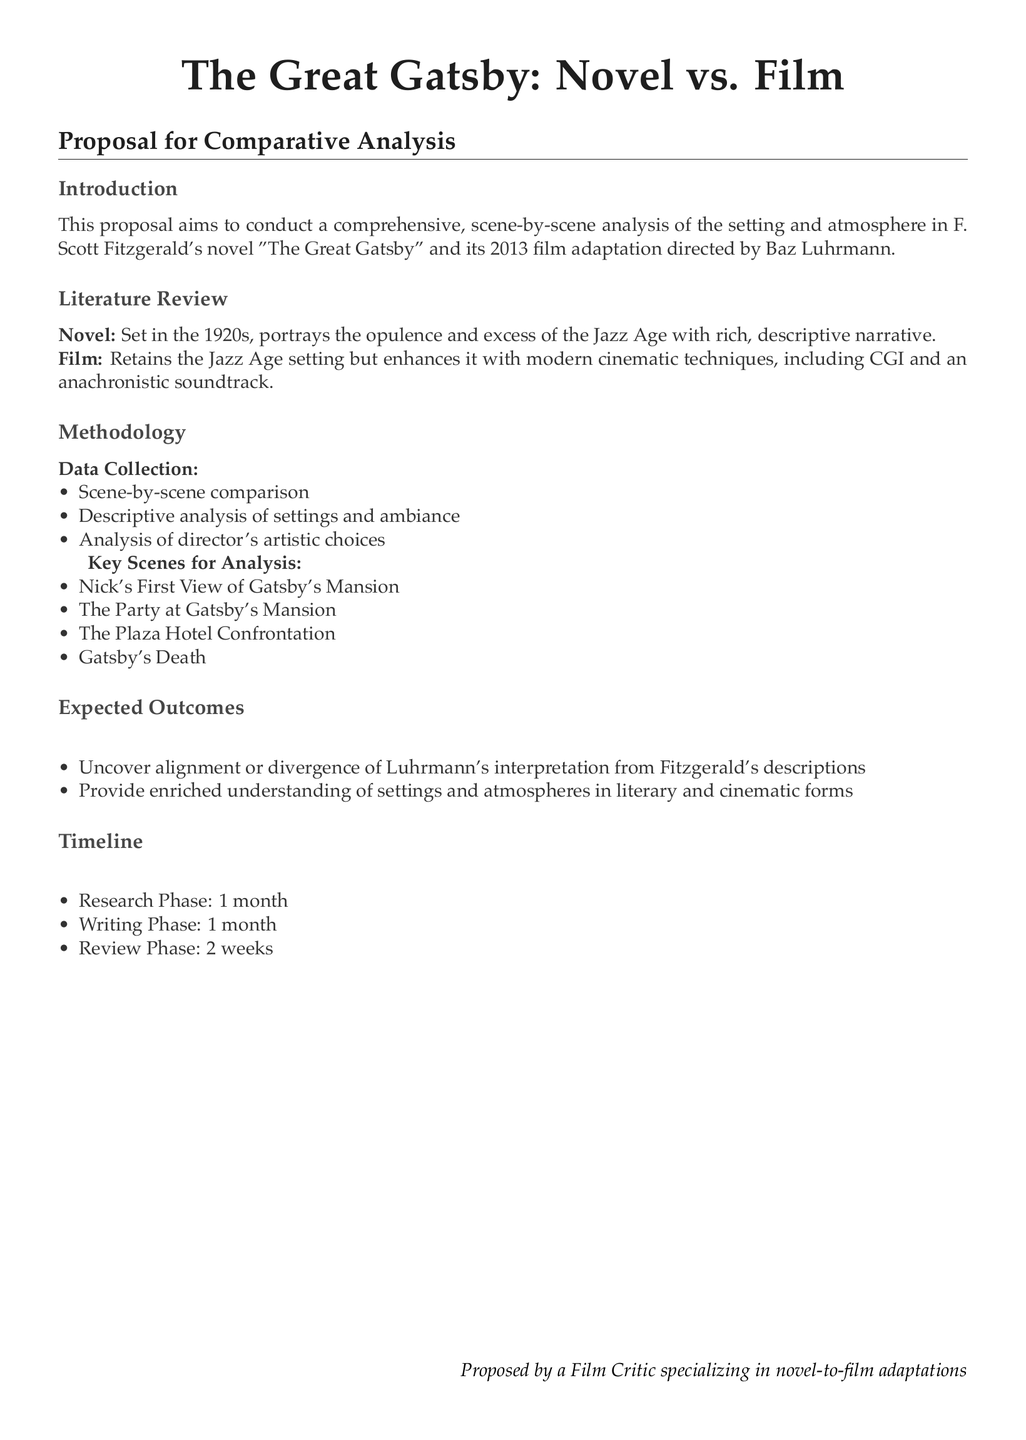What is the title of the proposal? The title is explicitly stated in the document’s header section.
Answer: The Great Gatsby: Novel vs. Film Who is the author of the novel being analyzed? The author is mentioned in the introduction section of the document.
Answer: F. Scott Fitzgerald What year was the film adaptation released? The year is included in the document alongside the film director's name.
Answer: 2013 How many key scenes for analysis are listed? The document enumerates the key scenes in a bullet list format.
Answer: Four What is the duration of the research phase? The duration is specified in the timeline section of the document.
Answer: 1 month What modern technique does the film use that enhances the setting? The document outlines specific techniques under “Film” in the literature review section.
Answer: CGI What aspect of Luhrmann's work will be compared to Fitzgerald's descriptions? The document specifies what will be analyzed in the expected outcomes section.
Answer: Artistic choices What is the main focus of this proposal? The focus is defined at the beginning of the proposal in the introduction.
Answer: Setting and atmosphere analysis 